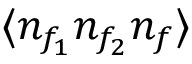<formula> <loc_0><loc_0><loc_500><loc_500>\langle n _ { f _ { 1 } } n _ { f _ { 2 } } n _ { f } \rangle</formula> 